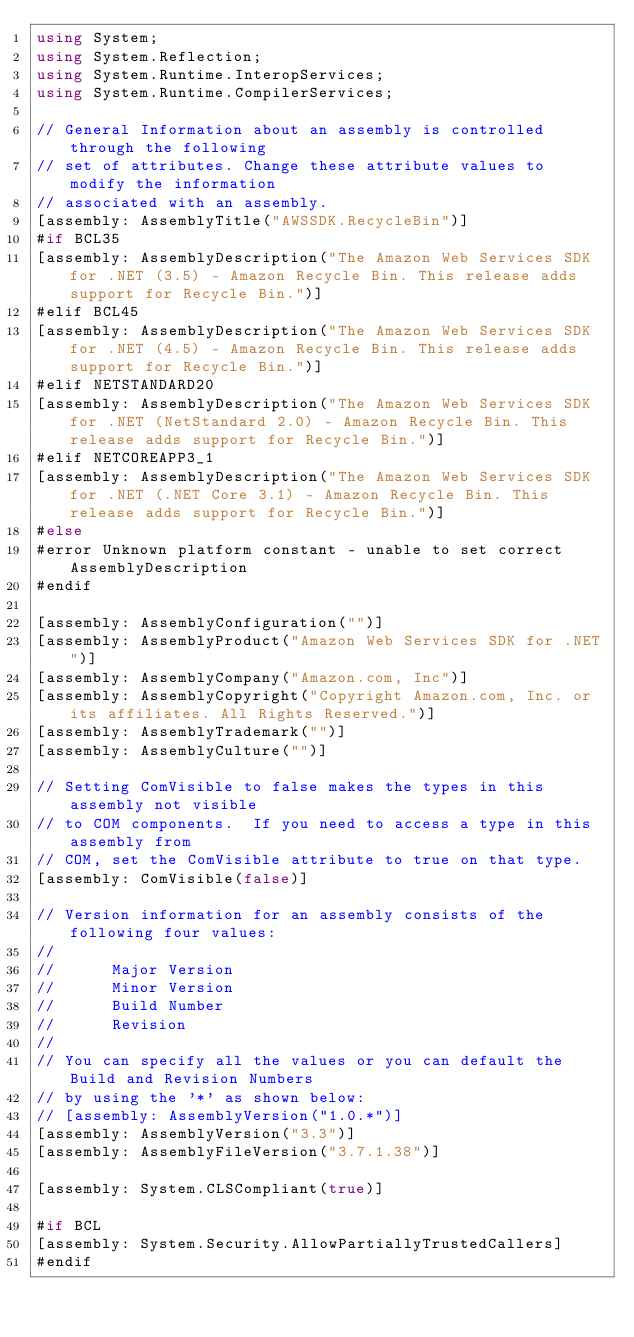Convert code to text. <code><loc_0><loc_0><loc_500><loc_500><_C#_>using System;
using System.Reflection;
using System.Runtime.InteropServices;
using System.Runtime.CompilerServices;

// General Information about an assembly is controlled through the following 
// set of attributes. Change these attribute values to modify the information
// associated with an assembly.
[assembly: AssemblyTitle("AWSSDK.RecycleBin")]
#if BCL35
[assembly: AssemblyDescription("The Amazon Web Services SDK for .NET (3.5) - Amazon Recycle Bin. This release adds support for Recycle Bin.")]
#elif BCL45
[assembly: AssemblyDescription("The Amazon Web Services SDK for .NET (4.5) - Amazon Recycle Bin. This release adds support for Recycle Bin.")]
#elif NETSTANDARD20
[assembly: AssemblyDescription("The Amazon Web Services SDK for .NET (NetStandard 2.0) - Amazon Recycle Bin. This release adds support for Recycle Bin.")]
#elif NETCOREAPP3_1
[assembly: AssemblyDescription("The Amazon Web Services SDK for .NET (.NET Core 3.1) - Amazon Recycle Bin. This release adds support for Recycle Bin.")]
#else
#error Unknown platform constant - unable to set correct AssemblyDescription
#endif

[assembly: AssemblyConfiguration("")]
[assembly: AssemblyProduct("Amazon Web Services SDK for .NET")]
[assembly: AssemblyCompany("Amazon.com, Inc")]
[assembly: AssemblyCopyright("Copyright Amazon.com, Inc. or its affiliates. All Rights Reserved.")]
[assembly: AssemblyTrademark("")]
[assembly: AssemblyCulture("")]

// Setting ComVisible to false makes the types in this assembly not visible 
// to COM components.  If you need to access a type in this assembly from 
// COM, set the ComVisible attribute to true on that type.
[assembly: ComVisible(false)]

// Version information for an assembly consists of the following four values:
//
//      Major Version
//      Minor Version 
//      Build Number
//      Revision
//
// You can specify all the values or you can default the Build and Revision Numbers 
// by using the '*' as shown below:
// [assembly: AssemblyVersion("1.0.*")]
[assembly: AssemblyVersion("3.3")]
[assembly: AssemblyFileVersion("3.7.1.38")]

[assembly: System.CLSCompliant(true)]

#if BCL
[assembly: System.Security.AllowPartiallyTrustedCallers]
#endif</code> 